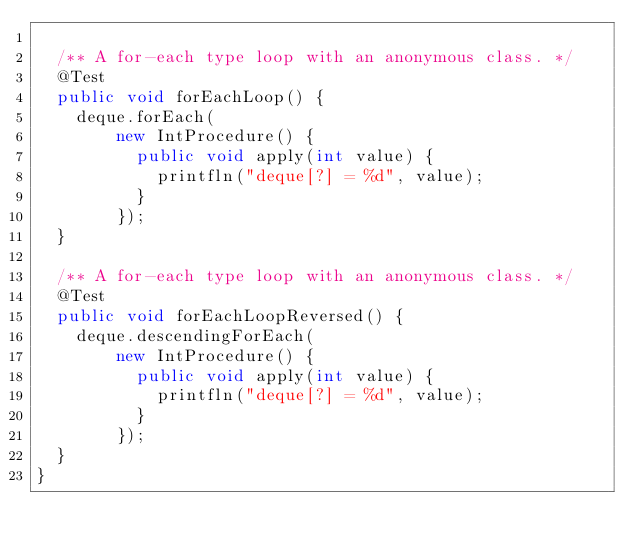Convert code to text. <code><loc_0><loc_0><loc_500><loc_500><_Java_>
  /** A for-each type loop with an anonymous class. */
  @Test
  public void forEachLoop() {
    deque.forEach(
        new IntProcedure() {
          public void apply(int value) {
            printfln("deque[?] = %d", value);
          }
        });
  }

  /** A for-each type loop with an anonymous class. */
  @Test
  public void forEachLoopReversed() {
    deque.descendingForEach(
        new IntProcedure() {
          public void apply(int value) {
            printfln("deque[?] = %d", value);
          }
        });
  }
}
</code> 